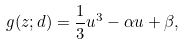<formula> <loc_0><loc_0><loc_500><loc_500>g ( z ; d ) = \frac { 1 } { 3 } u ^ { 3 } - \alpha u + \beta ,</formula> 